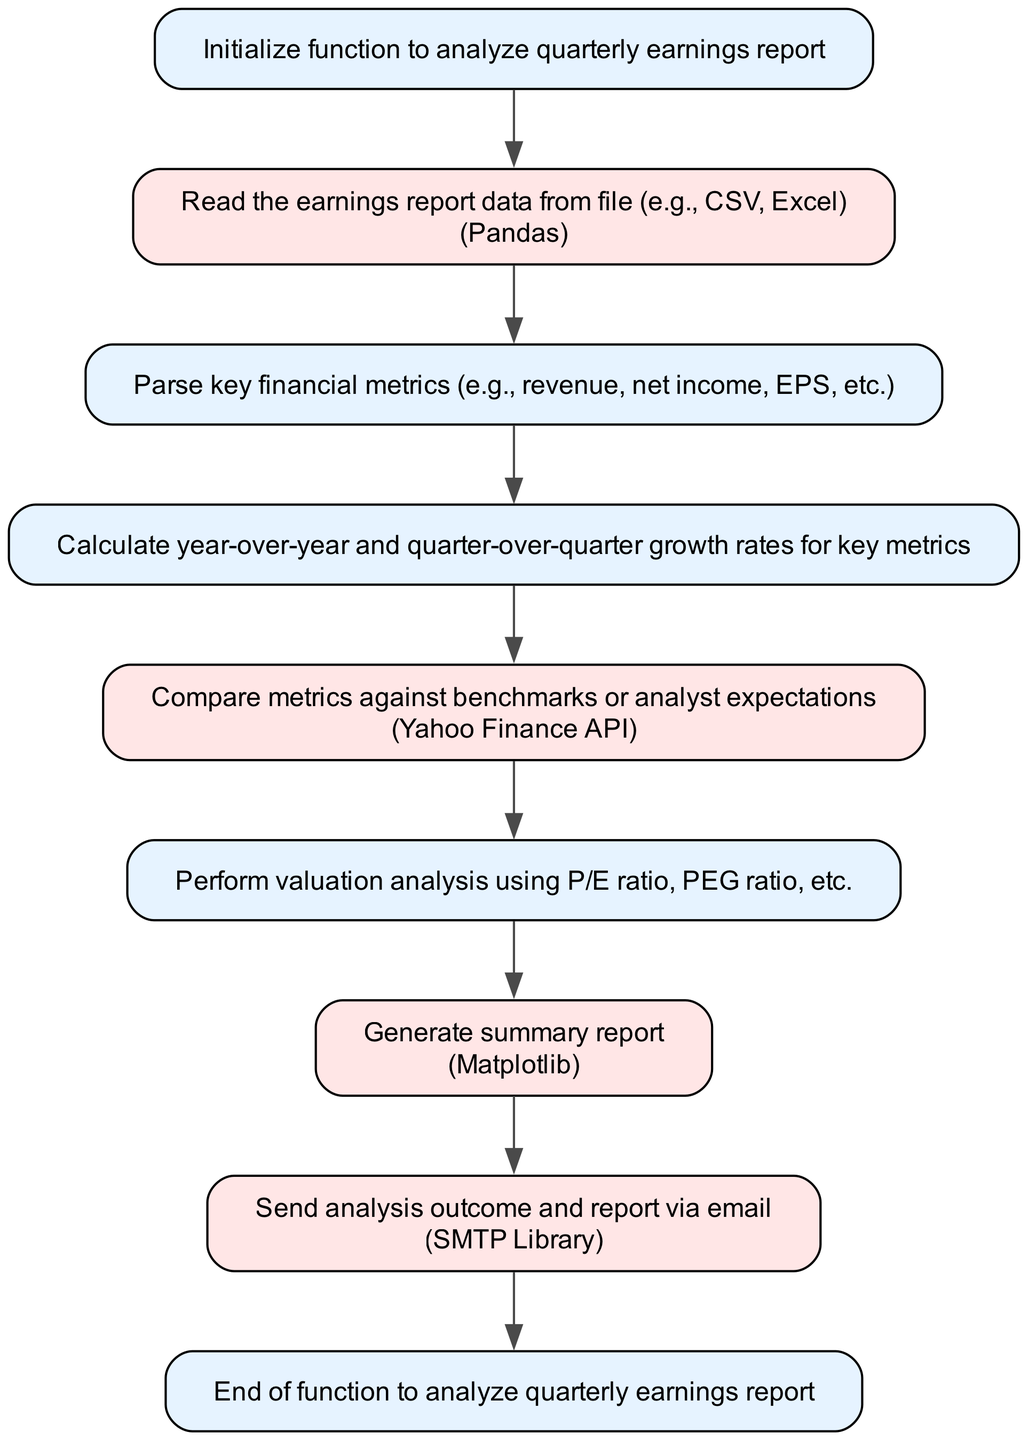What is the first step in the function? The first step in the flowchart is labeled "start" and indicates the initialization of the function to analyze the quarterly earnings report.
Answer: Initialize function to analyze quarterly earnings report How many steps are there in the process? To determine the total number of steps, we count each individual element within the diagram, including the start and end nodes. There are 9 steps in total.
Answer: 9 What does the "read_file" step utilize for reading data? The "read_file" step specifies that it uses "Pandas" to read the earnings report data from a file.
Answer: Pandas Which step follows "calculate_growth"? The step that follows "calculate_growth" in the flowchart is "benchmark_comparison", indicating the sequence of operations in the analysis.
Answer: benchmark_comparison What entity is used for sending notifications? The flowchart indicates that the outcome and report are sent via email using the "SMTP Library".
Answer: SMTP Library Which analysis step involves P/E ratio? The "valuation_analysis" step is where valuation is performed using metrics such as P/E ratio, indicating its role in this part of the function.
Answer: valuation_analysis Explain how metrics are compared. In the "benchmark_comparison" step, key financial metrics are compared against benchmarks or analyst expectations, emphasizing the evaluation procedure.
Answer: Compare metrics against benchmarks or analyst expectations How does the function end? The flowchart ends with a node labeled "end," which signifies the conclusion of the function for analyzing quarterly earnings reports.
Answer: End of function to analyze quarterly earnings report 